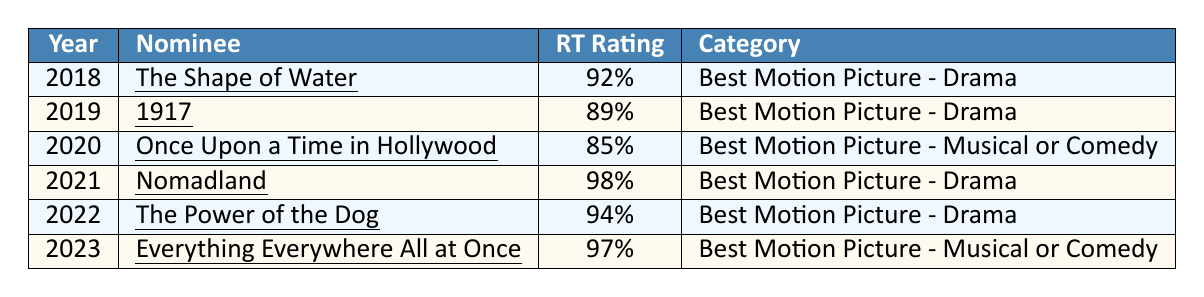What is the highest Rotten Tomatoes rating among the nominees? The table shows the ratings for each nominee, with "Nomadland" having the highest rating at 98%.
Answer: 98% Which movie from the table was nominated in 2019? The table lists the nominees by year, and in 2019, "1917" was nominated.
Answer: 1917 How many movies have a Rotten Tomatoes rating of 90% or higher? A visual check of the ratings reveals that "The Shape of Water," "Nomadland," "The Power of the Dog," and "Everything Everywhere All at Once" all have ratings above 90%. This totals four films.
Answer: 4 What is the difference in Rotten Tomatoes ratings between the films nominated in 2020 and 2021? In 2020, the rating is 85% for "Once Upon a Time in Hollywood," and in 2021, it is 98% for "Nomadland." The difference is 98% - 85% = 13%.
Answer: 13% Did any films nominated in 2022 have a higher rating than those in 2018? "The Power of the Dog" has a rating of 94%, while "The Shape of Water" from 2018 has a rating of 92%. Therefore, 94% (2022) is higher than 92% (2018), making this statement true.
Answer: Yes What is the average Rotten Tomatoes rating of the films listed for 2018, 2019, and 2020? The ratings for these years are 92%, 89%, and 85%. The average is calculated as follows: (92 + 89 + 85) / 3 = 266 / 3 = 88.67%.
Answer: 88.67% Which categories have the highest ratings in the table? The table shows "Best Motion Picture - Drama" with ratings of 98%, 94%, and 92%, while "Best Motion Picture - Musical or Comedy" has ratings of 85% and 97%. The highest rating is in the drama category with 98%.
Answer: Best Motion Picture - Drama How many nominees in the table belong to the "Best Motion Picture - Drama" category? Examining the category column reveals there are four films categorized as "Best Motion Picture - Drama" (2018, 2019, 2021, and 2022).
Answer: 4 What movie has the lowest Rotten Tomatoes rating in the table? By inspecting the ratings, "Once Upon a Time in Hollywood" has the lowest rating of 85% among all nominees listed.
Answer: Once Upon a Time in Hollywood Which two movies have consecutive years of nominations and how do their ratings compare? "1917" (2019) and "Once Upon a Time in Hollywood" (2020) are consecutive nominees. "1917" has a rating of 89%, while "Once Upon a Time in Hollywood" has a lower rating of 85%.
Answer: 1917 and Once Upon a Time in Hollywood; 89% vs. 85% 